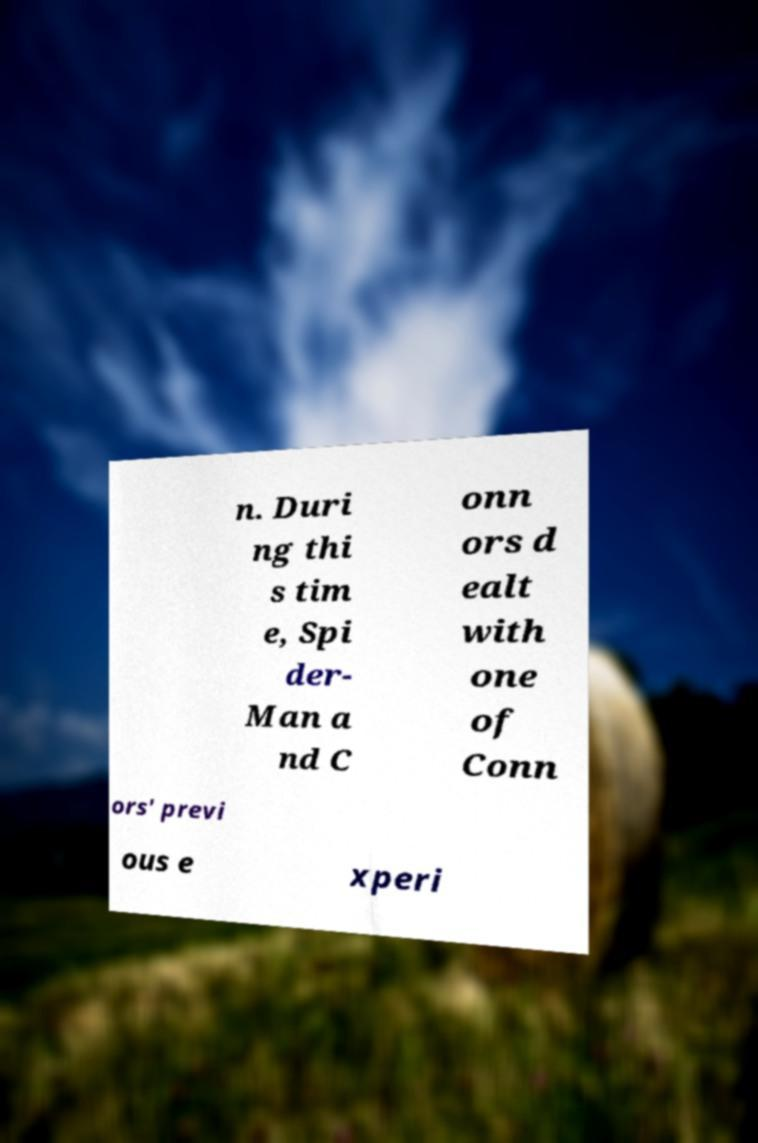Please read and relay the text visible in this image. What does it say? n. Duri ng thi s tim e, Spi der- Man a nd C onn ors d ealt with one of Conn ors' previ ous e xperi 